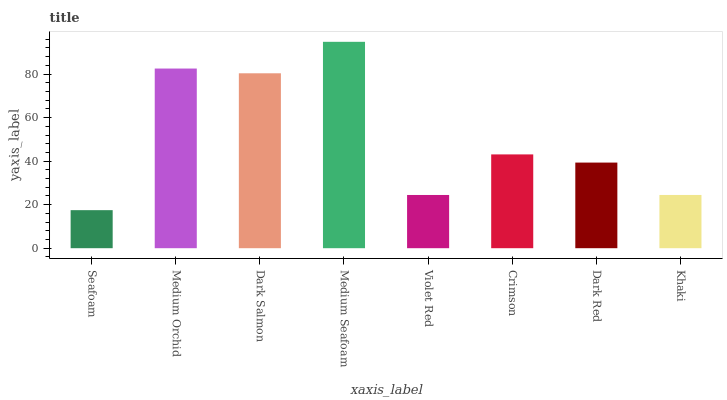Is Seafoam the minimum?
Answer yes or no. Yes. Is Medium Seafoam the maximum?
Answer yes or no. Yes. Is Medium Orchid the minimum?
Answer yes or no. No. Is Medium Orchid the maximum?
Answer yes or no. No. Is Medium Orchid greater than Seafoam?
Answer yes or no. Yes. Is Seafoam less than Medium Orchid?
Answer yes or no. Yes. Is Seafoam greater than Medium Orchid?
Answer yes or no. No. Is Medium Orchid less than Seafoam?
Answer yes or no. No. Is Crimson the high median?
Answer yes or no. Yes. Is Dark Red the low median?
Answer yes or no. Yes. Is Medium Orchid the high median?
Answer yes or no. No. Is Medium Seafoam the low median?
Answer yes or no. No. 